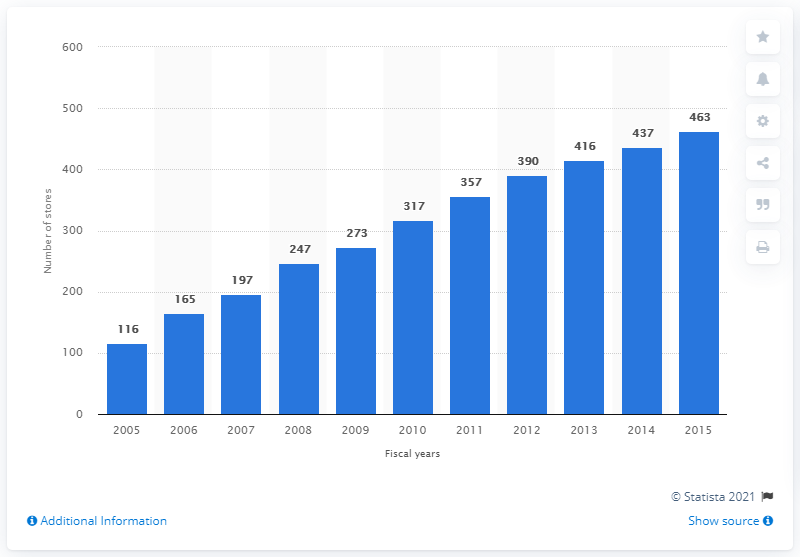Indicate a few pertinent items in this graphic. In 2015, there were 463 Apple stores. 